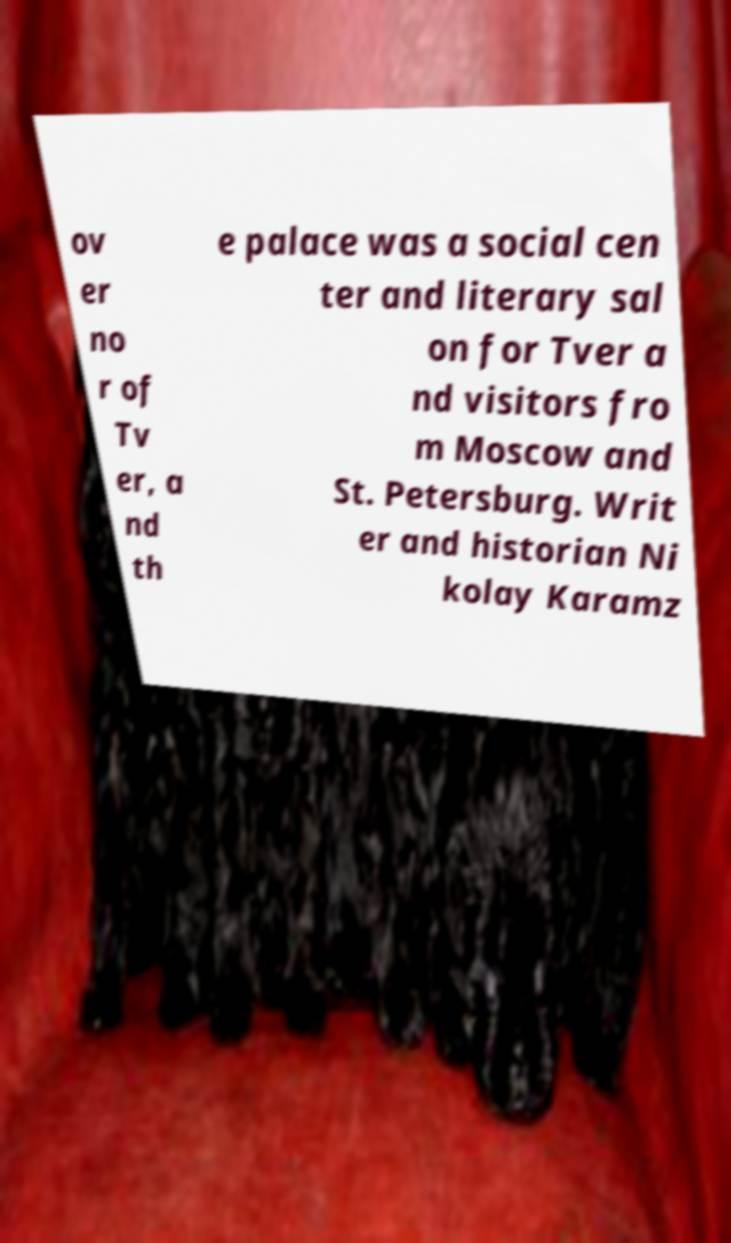Can you accurately transcribe the text from the provided image for me? ov er no r of Tv er, a nd th e palace was a social cen ter and literary sal on for Tver a nd visitors fro m Moscow and St. Petersburg. Writ er and historian Ni kolay Karamz 